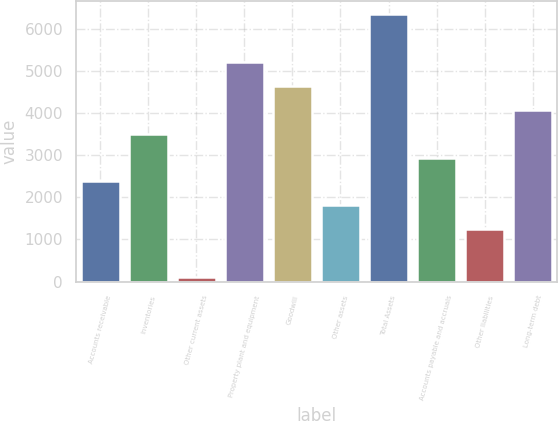Convert chart. <chart><loc_0><loc_0><loc_500><loc_500><bar_chart><fcel>Accounts receivable<fcel>Inventories<fcel>Other current assets<fcel>Property plant and equipment<fcel>Goodwill<fcel>Other assets<fcel>Total Assets<fcel>Accounts payable and accruals<fcel>Other liabilities<fcel>Long-term debt<nl><fcel>2376<fcel>3508<fcel>112<fcel>5206<fcel>4640<fcel>1810<fcel>6338<fcel>2942<fcel>1244<fcel>4074<nl></chart> 